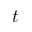<formula> <loc_0><loc_0><loc_500><loc_500>t</formula> 